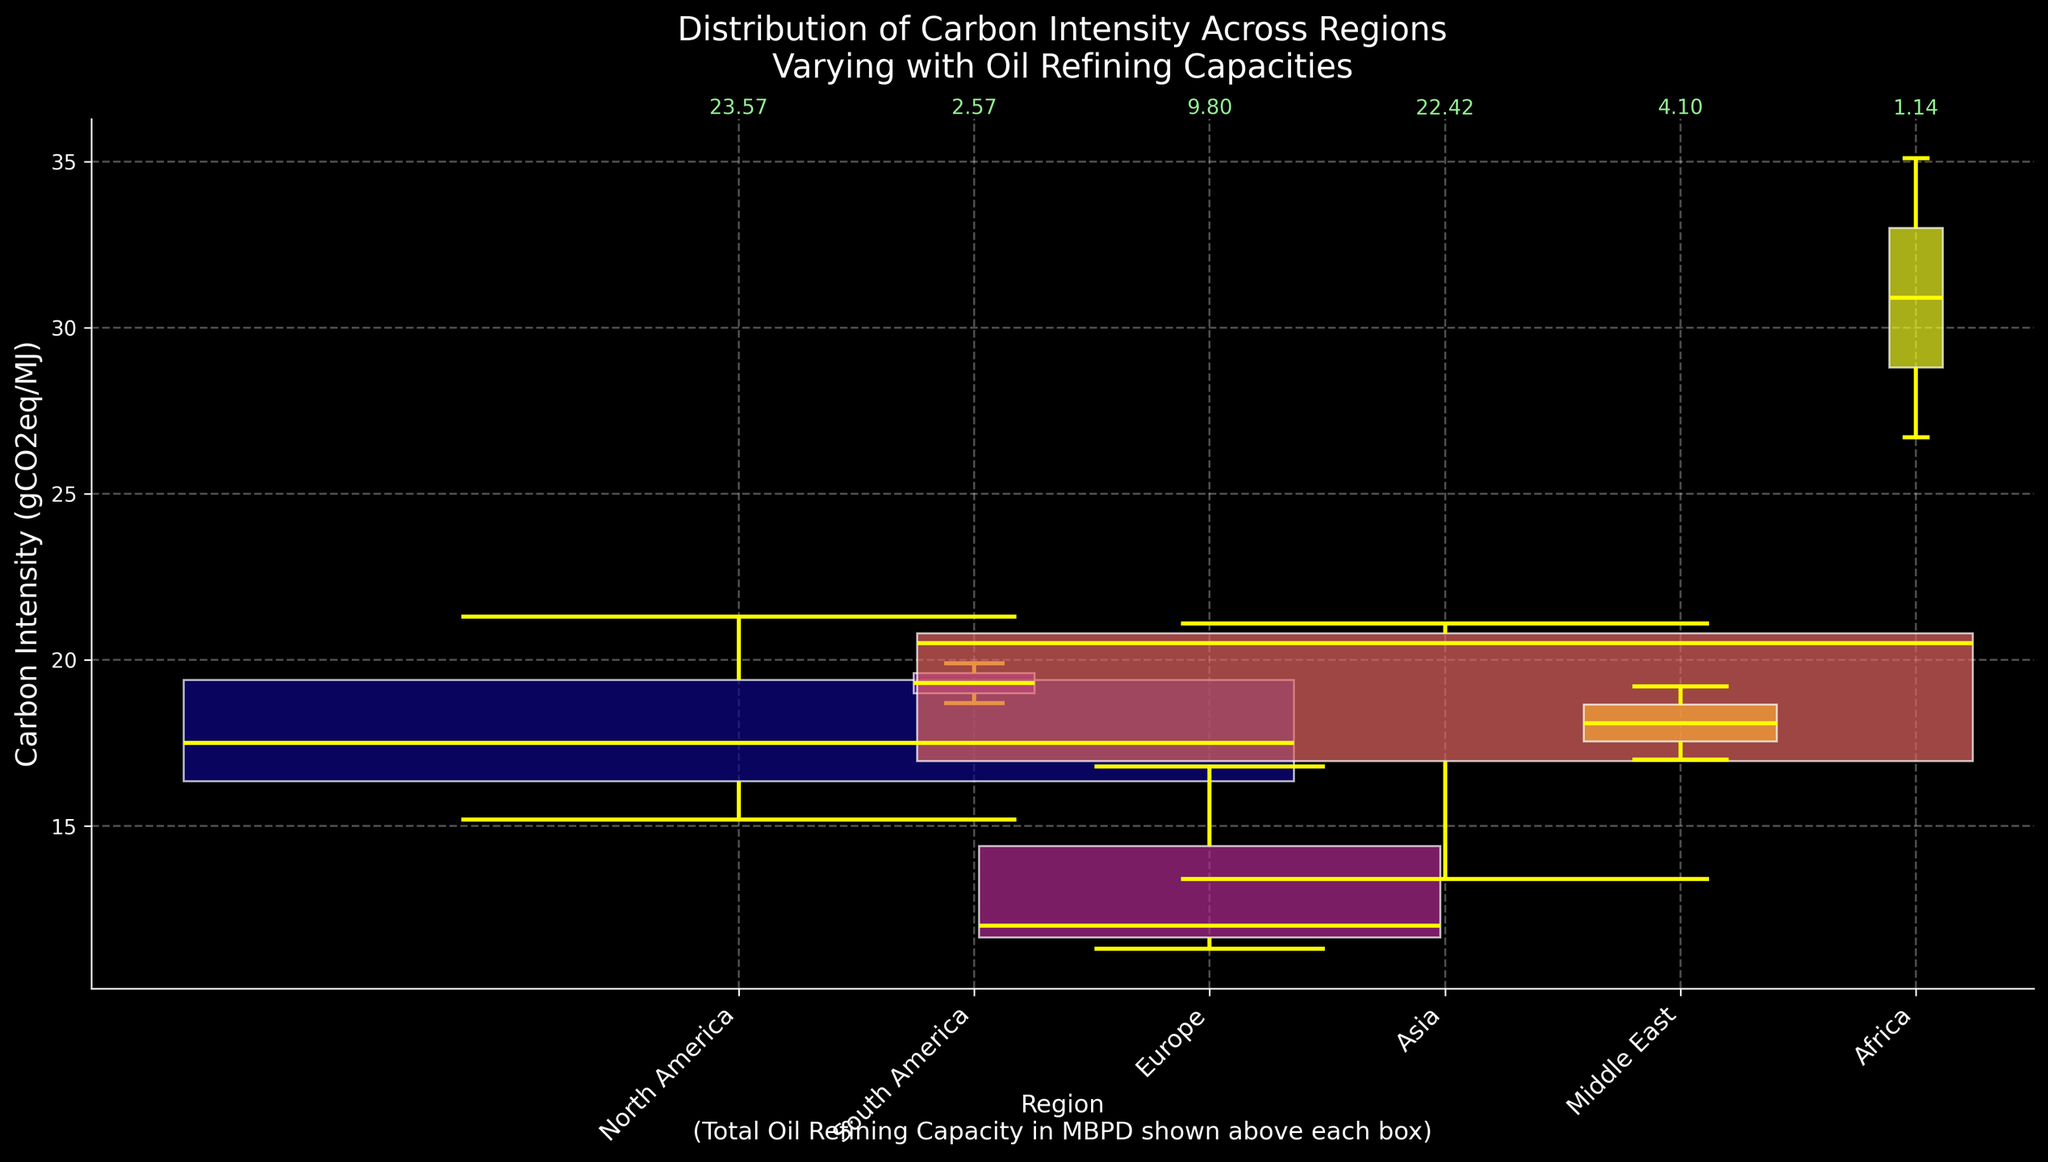Which region has the highest median Carbon Intensity? The median value for each region is the middle value of their respective Carbon Intensity data shown in the box plots. The region with the highest median value is visible by identifying the highest median line within the box plots.
Answer: Africa What is the width of the North America box plot? The width of each box plot is proportional to the total Oil Refining Capacity for that region. In North America, the total Oil Refining Capacity is the sum of capacities for USA, Canada, and Mexico. This width is indicated visually by the horizontal size of the box.
Answer: 4.71 What's the range of Carbon Intensity values for South America? The range can be determined by looking at the minimum and maximum whiskers of the box plot for South America. Identify the lowest and highest points of the tails/wiskers of the South America box plot.
Answer: 18.7 to 19.9 Which region has the smallest Oil Refining Capacity? The region with the smallest Oil Refining Capacity can be found by identifying the narrowest (thinnest) box plots. The value is also annotated above each box plot.
Answer: Africa Which regions have higher Carbon Intensity variability? Carbon Intensity variability is indicated by the height of the box plots. Taller box plots signify greater variability. Compare the heights of the boxes to identify the regions with the highest variability.
Answer: Africa, North America What is the median Carbon Intensity for Europe? The median is the central horizontal line within the box plot for Europe. Find this line in the Europe box plot to get the median value.
Answer: 12.0 How does the Carbon Intensity of Asia compare to Europe? Compare the positioning of the box plots for Asia and Europe. The median line of the Asia box plot lies higher than Europe, indicating that Asia typically has higher Carbon Intensity values overall.
Answer: Asia is higher Which region has the widest box plot and why? The width of the box plots corresponds to the total Oil Refining Capacity. Find the widest box plot to determine the region and the reason for the width, which is higher Oil Refining Capacity.
Answer: North America What can be inferred about the environmental impact between North America and South America based on Carbon Intensity distribution? Examine both the median line and the range of values in the box plots for North America and South America. Generally, North America has a lower median but greater variability, while South America has a relatively high median with less spread. This suggests different environmental impact profiles regarding Carbon Intensity.
Answer: North America has lower median, higher variability; South America has higher median, lower variability 